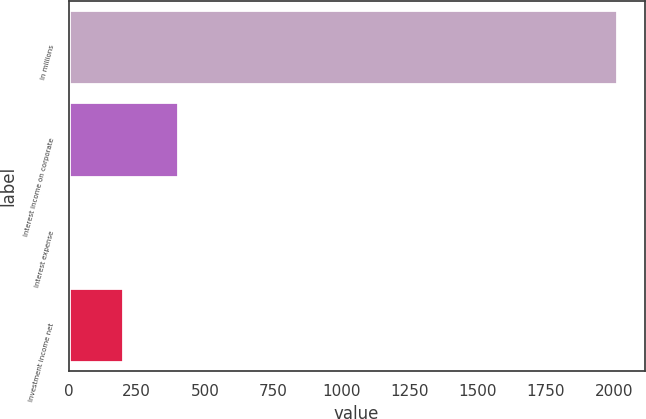Convert chart. <chart><loc_0><loc_0><loc_500><loc_500><bar_chart><fcel>In millions<fcel>Interest income on corporate<fcel>Interest expense<fcel>Investment income net<nl><fcel>2012<fcel>402.48<fcel>0.1<fcel>201.29<nl></chart> 